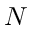<formula> <loc_0><loc_0><loc_500><loc_500>N</formula> 